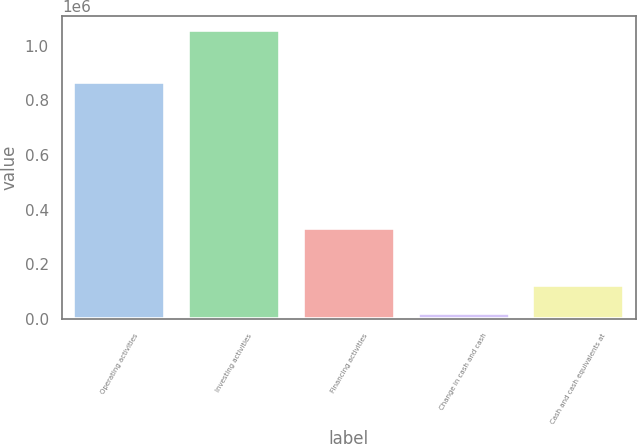Convert chart to OTSL. <chart><loc_0><loc_0><loc_500><loc_500><bar_chart><fcel>Operating activities<fcel>Investing activities<fcel>Financing activities<fcel>Change in cash and cash<fcel>Cash and cash equivalents at<nl><fcel>867090<fcel>1.05631e+06<fcel>331679<fcel>21125<fcel>124643<nl></chart> 